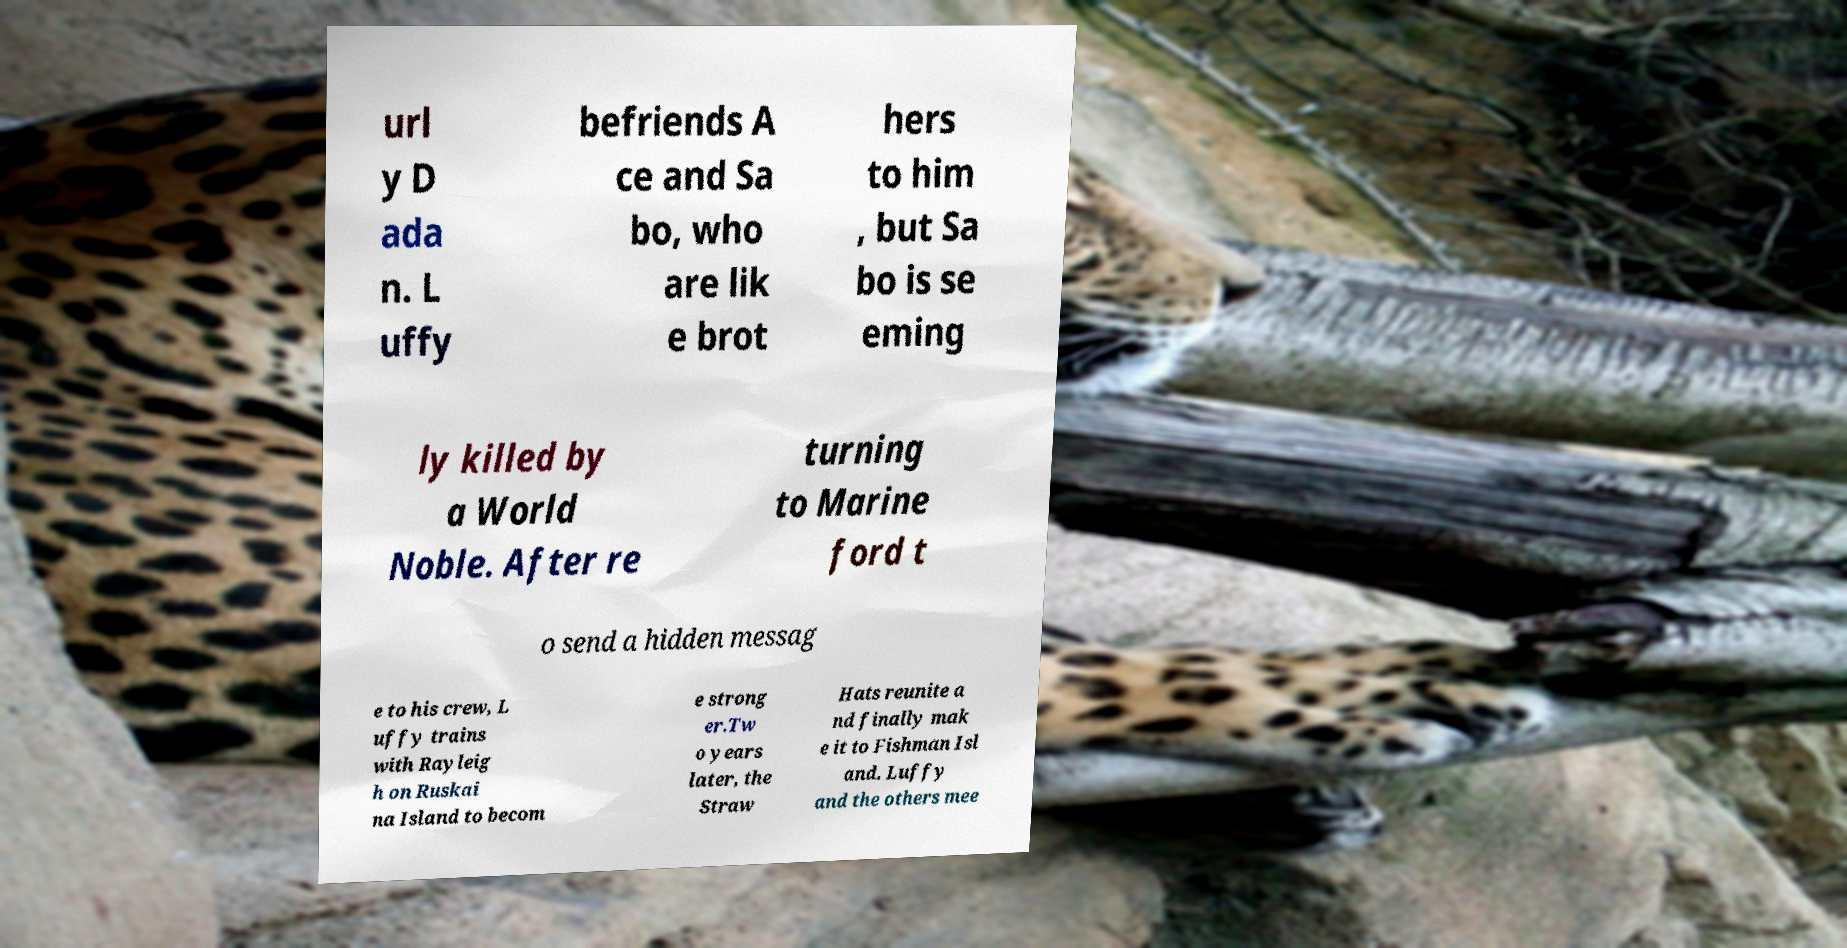Can you read and provide the text displayed in the image?This photo seems to have some interesting text. Can you extract and type it out for me? url y D ada n. L uffy befriends A ce and Sa bo, who are lik e brot hers to him , but Sa bo is se eming ly killed by a World Noble. After re turning to Marine ford t o send a hidden messag e to his crew, L uffy trains with Rayleig h on Ruskai na Island to becom e strong er.Tw o years later, the Straw Hats reunite a nd finally mak e it to Fishman Isl and. Luffy and the others mee 